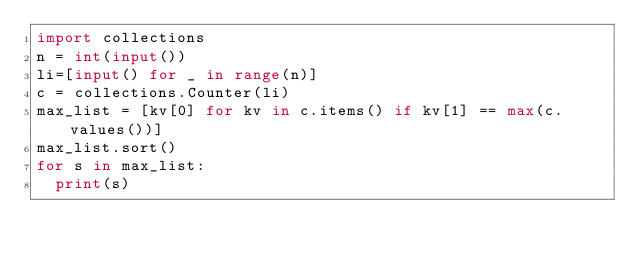Convert code to text. <code><loc_0><loc_0><loc_500><loc_500><_Python_>import collections
n = int(input())
li=[input() for _ in range(n)]
c = collections.Counter(li)
max_list = [kv[0] for kv in c.items() if kv[1] == max(c.values())]
max_list.sort()
for s in max_list:
  print(s)</code> 